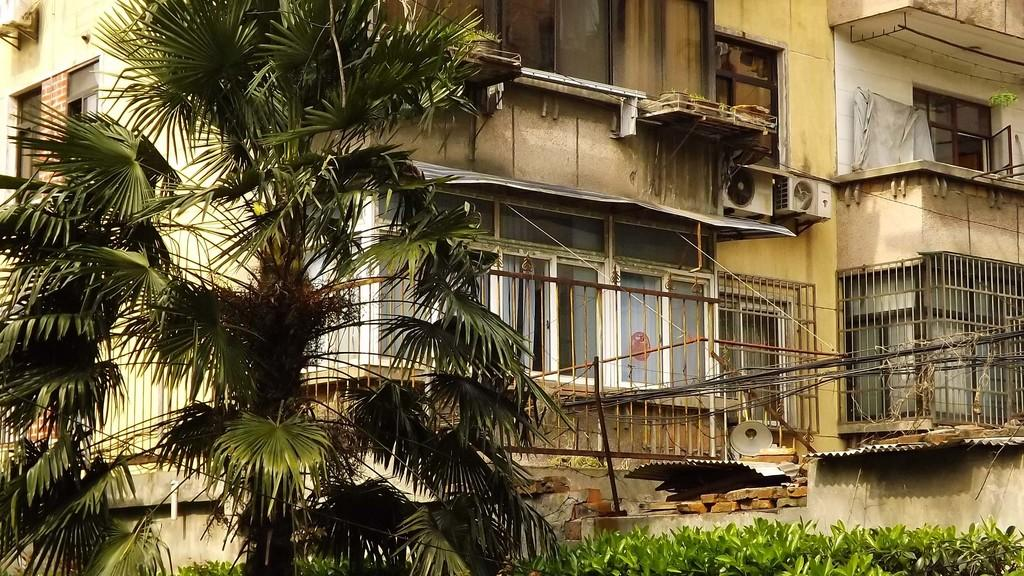What type of structure is visible in the image? There is a building in the image. What architectural features can be seen on the building? There are grilles, railing, windows, metal panels, and bricks visible on the building. Are there any natural elements present in the image? Yes, there are plants and a tree in the image. What is visible at the bottom portion of the image? Leaves are visible at the bottom portion of the image. Where is the grandmother sitting in the image? There is no grandmother present in the image. What type of vegetable is growing in the image? There are no vegetables visible in the image, only plants and a tree. 